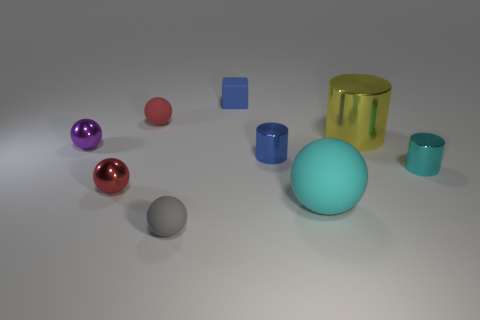Subtract all tiny blue metal cylinders. How many cylinders are left? 2 Subtract 1 cylinders. How many cylinders are left? 2 Subtract all cyan balls. How many balls are left? 4 Subtract all yellow balls. Subtract all gray cylinders. How many balls are left? 5 Subtract all cylinders. How many objects are left? 6 Subtract all yellow metallic blocks. Subtract all small purple balls. How many objects are left? 8 Add 7 red things. How many red things are left? 9 Add 9 large cyan matte objects. How many large cyan matte objects exist? 10 Subtract 2 red spheres. How many objects are left? 7 